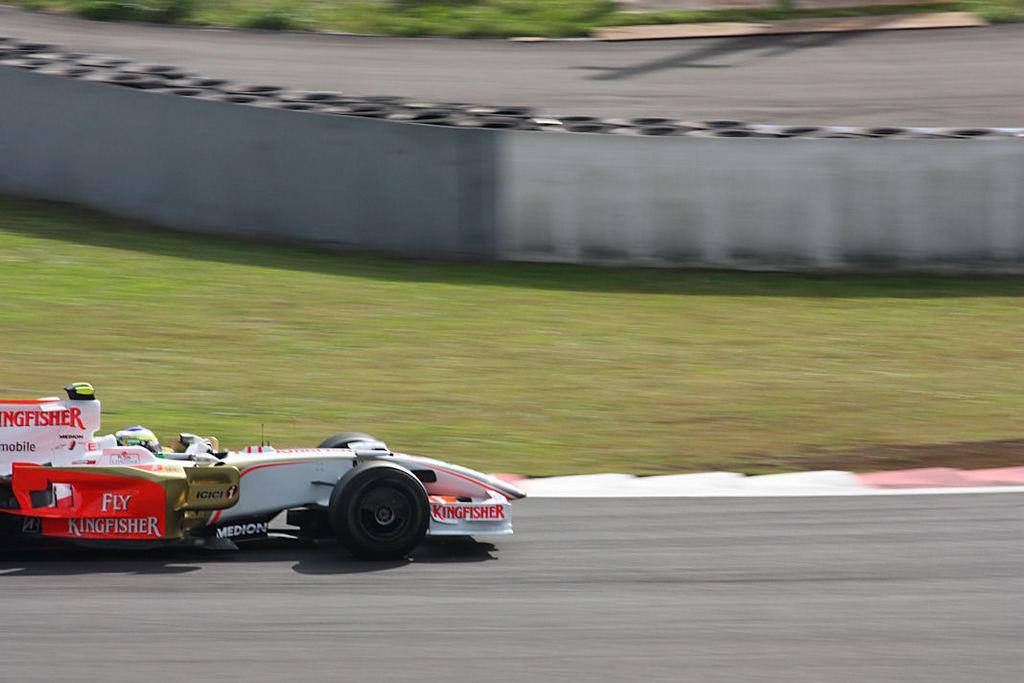What is the main subject of the image? There is a vehicle on the road in the image. What can be seen in the background of the image? There is grass, a wall, another road, and an unspecified object visible in the background of the image. Can you describe the road in the image? The road is visible in the foreground, and there is another road visible in the background. What type of wound can be seen on the vehicle in the image? There is no wound visible on the vehicle in the image. What role does air play in the image? Air is not a subject or object in the image; it is a natural element that surrounds everything. 